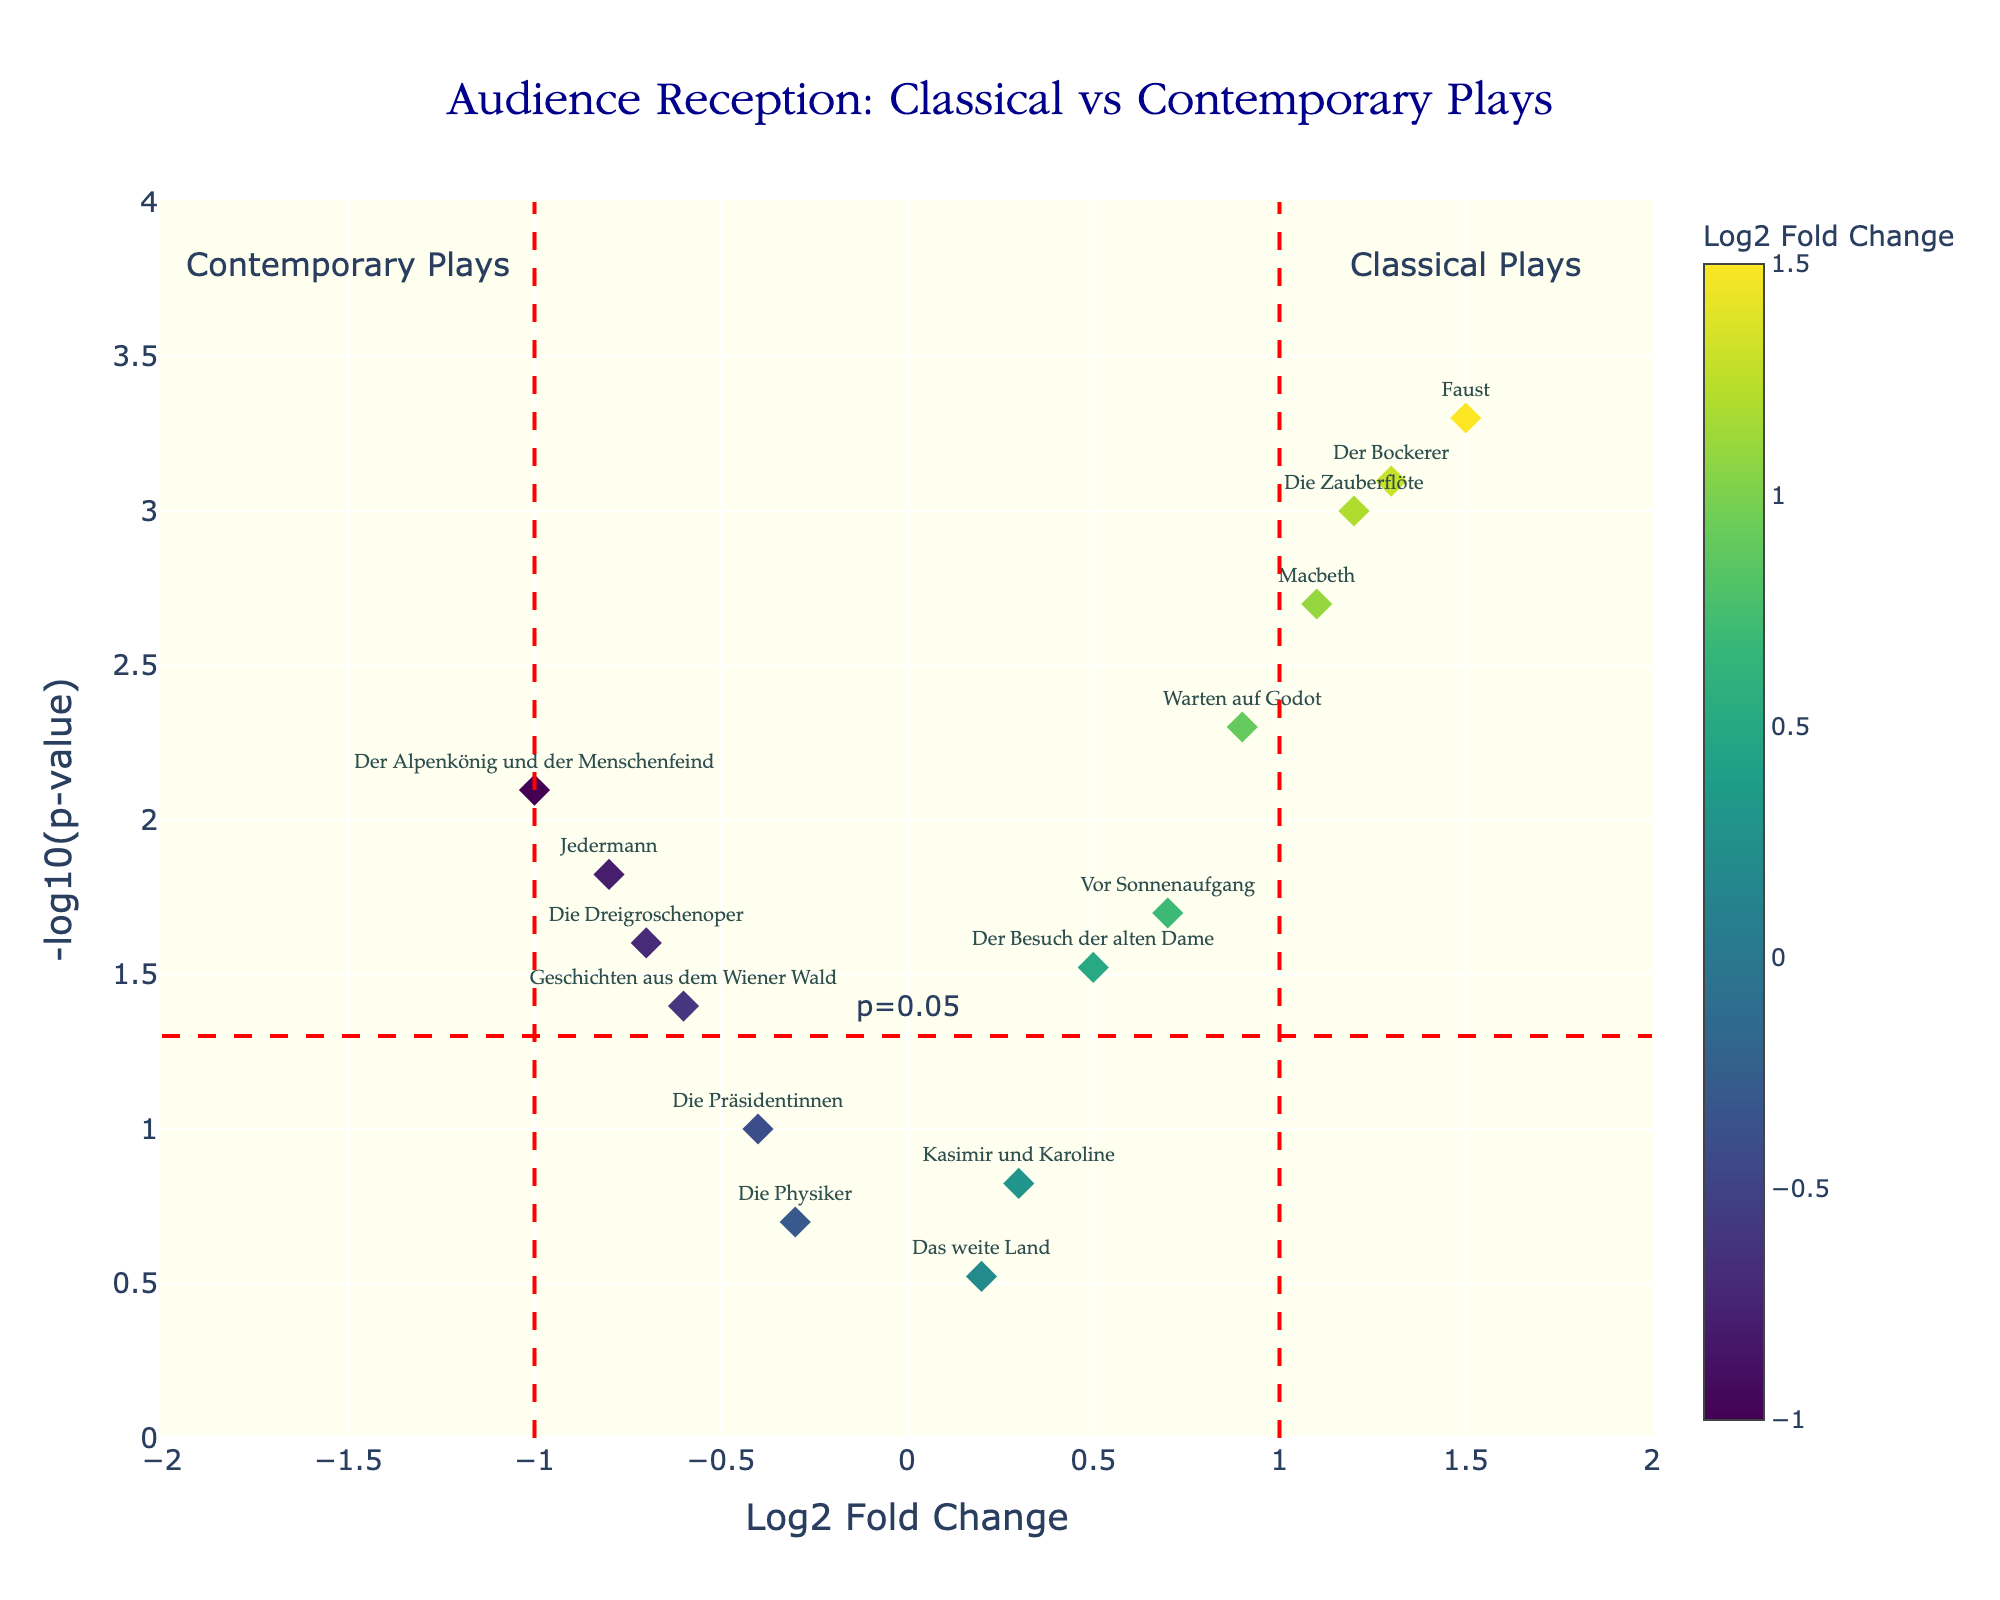What is the title of the figure? Look at the plot's top where the title is displayed.
Answer: Audience Reception: Classical vs Contemporary Plays How many plays have a Log2 Fold Change greater than 1? Identify points on the x-axis where Log2 Fold Change is greater than 1 and count them. Specifically, look for plays to the right of the vertical threshold line at 1.
Answer: Four plays Which play has the highest -log10(p-value)? Check the y-axis values and locate the point at the highest position, which corresponds to the highest -log10(p-value).
Answer: Faust Is there any play with a Log2 Fold Change of exactly 0? Locate the x-axis position where Log2 Fold Change is 0 and check if any point is plotted there.
Answer: No What color indicates a negative Log2 Fold Change? Observe the color scale used in the figure, noting the colors on the negative side of the Log2 Fold Change.
Answer: Darker shades on the color scale Which play has the lowest Log2 Fold Change and a statistically significant p-value (p < 0.05)? Identify the play with the smallest Log2 Fold Change to the left of the vertical line at -1 and check its -log10(p-value).
Answer: Der Alpenkönig und der Menschenfeind How many plays have statistically significant p-values (< 0.05)? Count the number of points above the horizontal threshold line for -log10(p-value) at 1.3 (-log10(0.05)).
Answer: Nine plays Which classical play has the most positive audience reception based on Log2 Fold Change? Identify classical plays on the right side of the vertical line at 1 and compare their Log2 Fold Change values.
Answer: Faust Are there more classical plays or contemporary plays on the plot? Examine the labels and identify if they relate to classical or contemporary plays, then count each group.
Answer: Classical plays What does the red horizontal line at -log10(p-value) of 1.3 represent? This line is typically used in volcano plots to denote a significance threshold.
Answer: p=0.05 